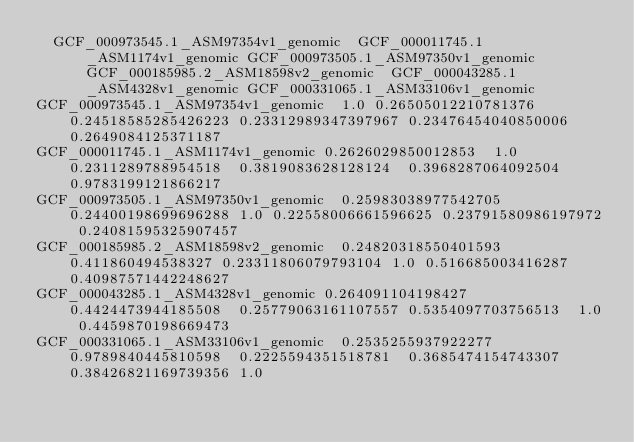<code> <loc_0><loc_0><loc_500><loc_500><_SQL_>	GCF_000973545.1_ASM97354v1_genomic	GCF_000011745.1_ASM1174v1_genomic	GCF_000973505.1_ASM97350v1_genomic	GCF_000185985.2_ASM18598v2_genomic	GCF_000043285.1_ASM4328v1_genomic	GCF_000331065.1_ASM33106v1_genomic
GCF_000973545.1_ASM97354v1_genomic	1.0	0.26505012210781376	0.24518585285426223	0.23312989347397967	0.23476454040850006	0.2649084125371187
GCF_000011745.1_ASM1174v1_genomic	0.2626029850012853	1.0	0.2311289788954518	0.3819083628128124	0.3968287064092504	0.9783199121866217
GCF_000973505.1_ASM97350v1_genomic	0.25983038977542705	0.24400198699696288	1.0	0.22558006661596625	0.23791580986197972	0.24081595325907457
GCF_000185985.2_ASM18598v2_genomic	0.24820318550401593	0.411860494538327	0.23311806079793104	1.0	0.516685003416287	0.40987571442248627
GCF_000043285.1_ASM4328v1_genomic	0.264091104198427	0.4424473944185508	0.25779063161107557	0.5354097703756513	1.0	0.4459870198669473
GCF_000331065.1_ASM33106v1_genomic	0.2535255937922277	0.9789840445810598	0.2225594351518781	0.3685474154743307	0.38426821169739356	1.0
</code> 